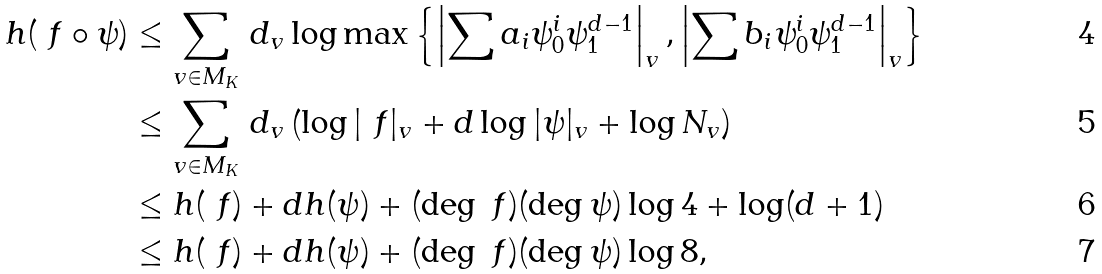Convert formula to latex. <formula><loc_0><loc_0><loc_500><loc_500>h ( \ f \circ \psi ) & \leq \sum _ { v \in M _ { K } } \, d _ { v } \log \max \left \{ \left | \sum a _ { i } \psi _ { 0 } ^ { i } \psi _ { 1 } ^ { d - 1 } \right | _ { v } , \left | \sum b _ { i } \psi _ { 0 } ^ { i } \psi _ { 1 } ^ { d - 1 } \right | _ { v } \right \} \\ & \leq \sum _ { v \in M _ { K } } \, d _ { v } \left ( \log | \ f | _ { v } + d \log | \psi | _ { v } + \log N _ { v } \right ) \\ & \leq h ( \ f ) + d h ( \psi ) + ( \deg \ f ) ( \deg \psi ) \log 4 + \log ( d + 1 ) \\ & \leq h ( \ f ) + d h ( \psi ) + ( \deg \ f ) ( \deg \psi ) \log 8 ,</formula> 